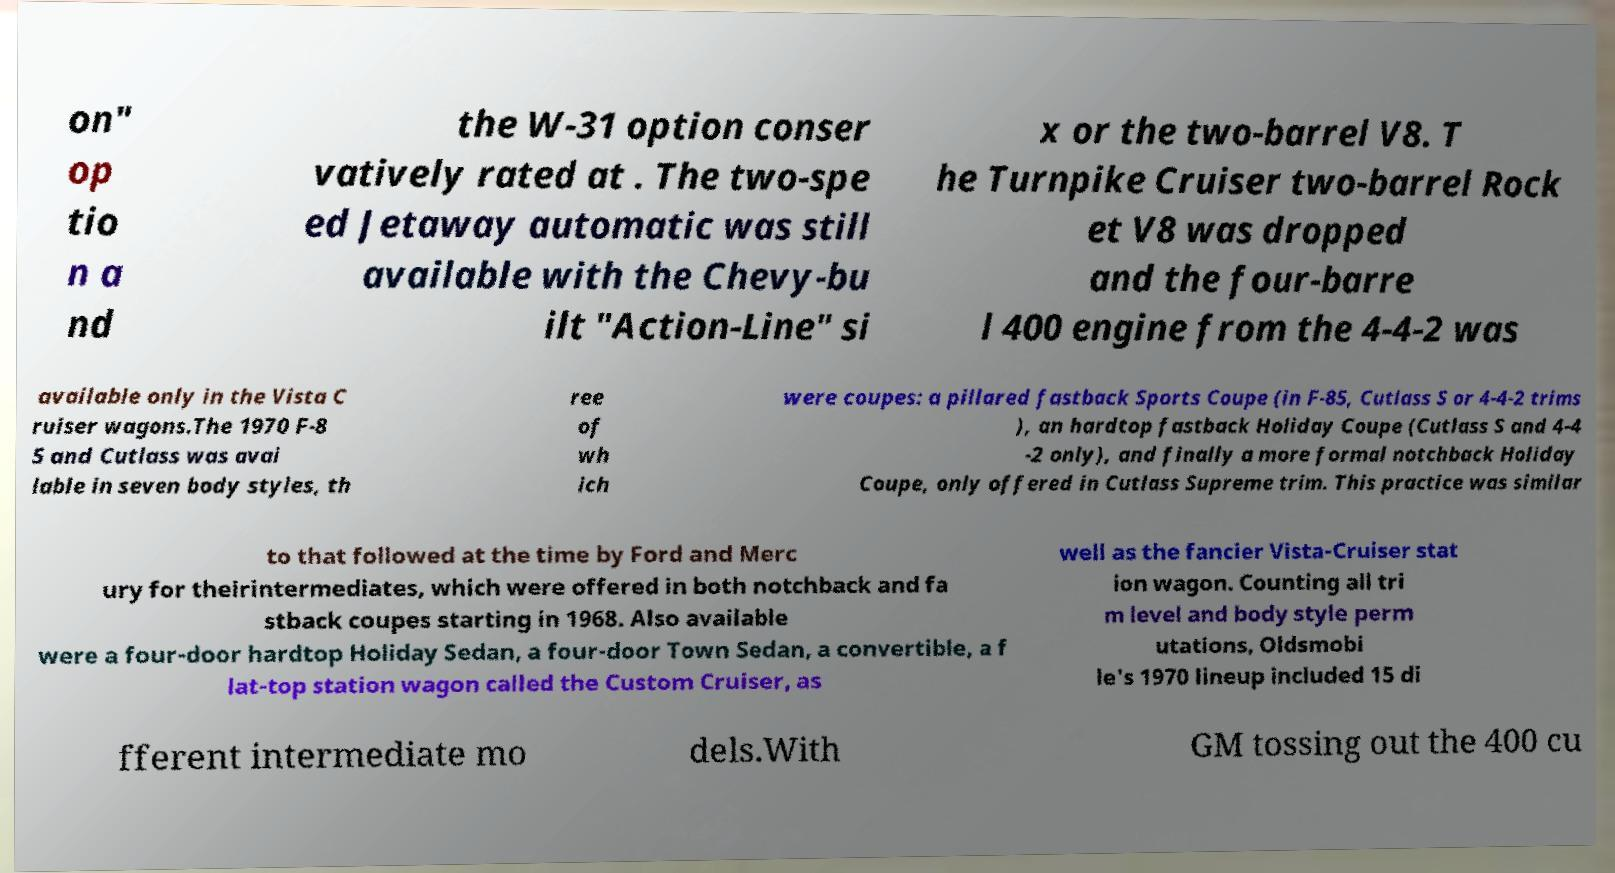Please read and relay the text visible in this image. What does it say? on" op tio n a nd the W-31 option conser vatively rated at . The two-spe ed Jetaway automatic was still available with the Chevy-bu ilt "Action-Line" si x or the two-barrel V8. T he Turnpike Cruiser two-barrel Rock et V8 was dropped and the four-barre l 400 engine from the 4-4-2 was available only in the Vista C ruiser wagons.The 1970 F-8 5 and Cutlass was avai lable in seven body styles, th ree of wh ich were coupes: a pillared fastback Sports Coupe (in F-85, Cutlass S or 4-4-2 trims ), an hardtop fastback Holiday Coupe (Cutlass S and 4-4 -2 only), and finally a more formal notchback Holiday Coupe, only offered in Cutlass Supreme trim. This practice was similar to that followed at the time by Ford and Merc ury for theirintermediates, which were offered in both notchback and fa stback coupes starting in 1968. Also available were a four-door hardtop Holiday Sedan, a four-door Town Sedan, a convertible, a f lat-top station wagon called the Custom Cruiser, as well as the fancier Vista-Cruiser stat ion wagon. Counting all tri m level and body style perm utations, Oldsmobi le's 1970 lineup included 15 di fferent intermediate mo dels.With GM tossing out the 400 cu 